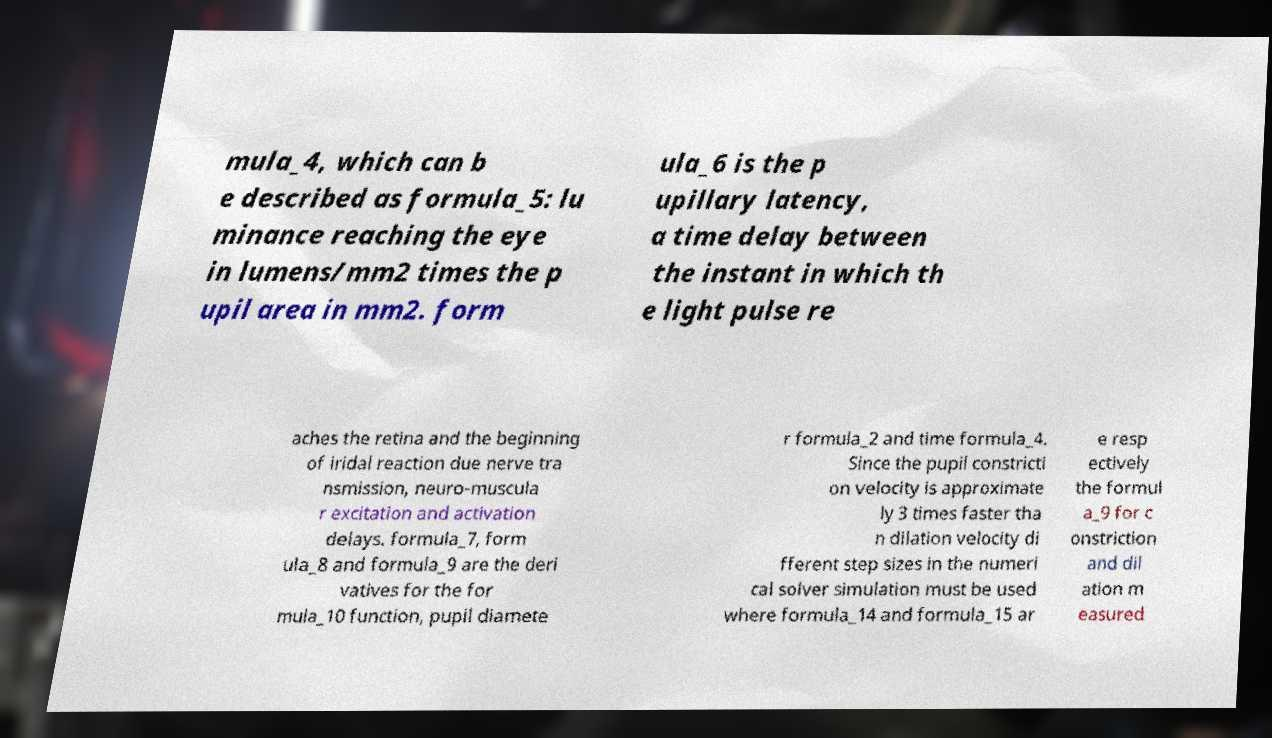Please identify and transcribe the text found in this image. mula_4, which can b e described as formula_5: lu minance reaching the eye in lumens/mm2 times the p upil area in mm2. form ula_6 is the p upillary latency, a time delay between the instant in which th e light pulse re aches the retina and the beginning of iridal reaction due nerve tra nsmission, neuro-muscula r excitation and activation delays. formula_7, form ula_8 and formula_9 are the deri vatives for the for mula_10 function, pupil diamete r formula_2 and time formula_4. Since the pupil constricti on velocity is approximate ly 3 times faster tha n dilation velocity di fferent step sizes in the numeri cal solver simulation must be used where formula_14 and formula_15 ar e resp ectively the formul a_9 for c onstriction and dil ation m easured 